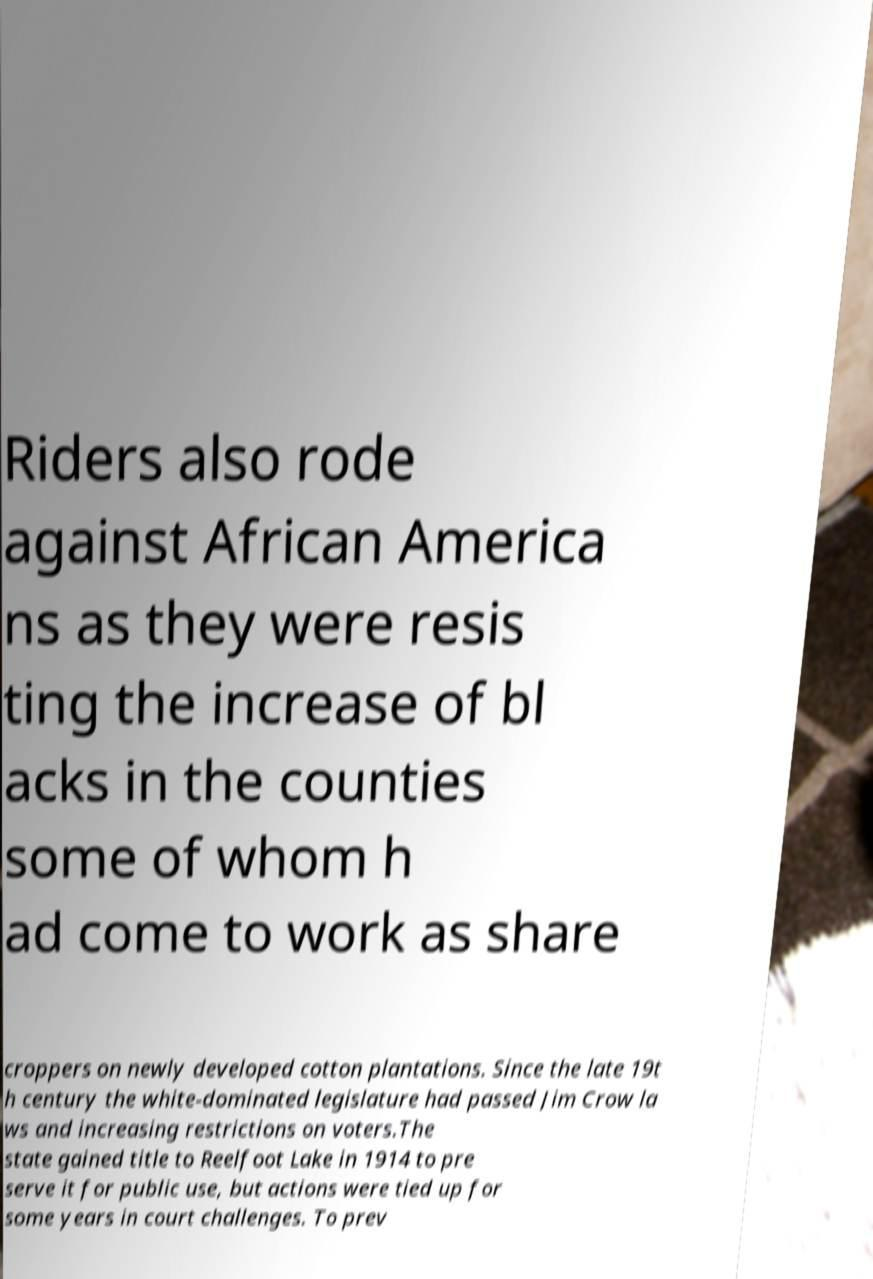For documentation purposes, I need the text within this image transcribed. Could you provide that? Riders also rode against African America ns as they were resis ting the increase of bl acks in the counties some of whom h ad come to work as share croppers on newly developed cotton plantations. Since the late 19t h century the white-dominated legislature had passed Jim Crow la ws and increasing restrictions on voters.The state gained title to Reelfoot Lake in 1914 to pre serve it for public use, but actions were tied up for some years in court challenges. To prev 